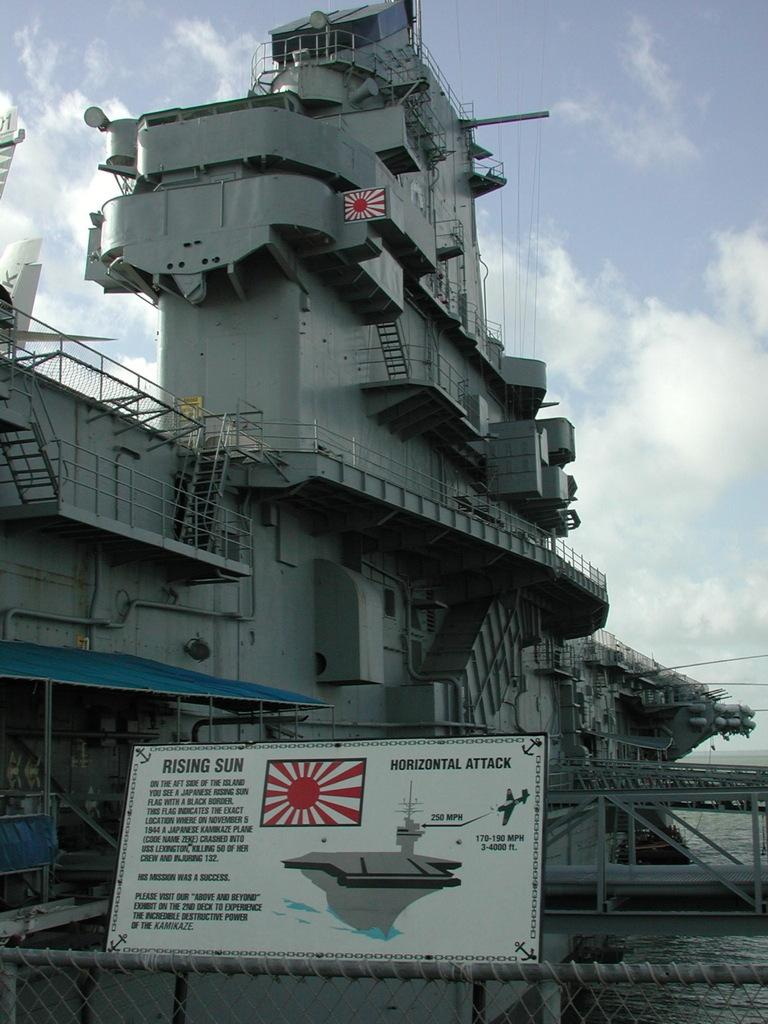What is the main subject of the image? The main subject of the image is a ship. Can you describe any specific features of the ship? Yes, the ship has stairs and a board. What is visible in the sky at the top of the image? There are clouds in the sky at the top of the image. How many accounts are visible on the ship in the image? There are no accounts present in the image; it features a ship with stairs and a board. What type of tail can be seen on the ship in the image? There is no tail present on the ship in the image. 